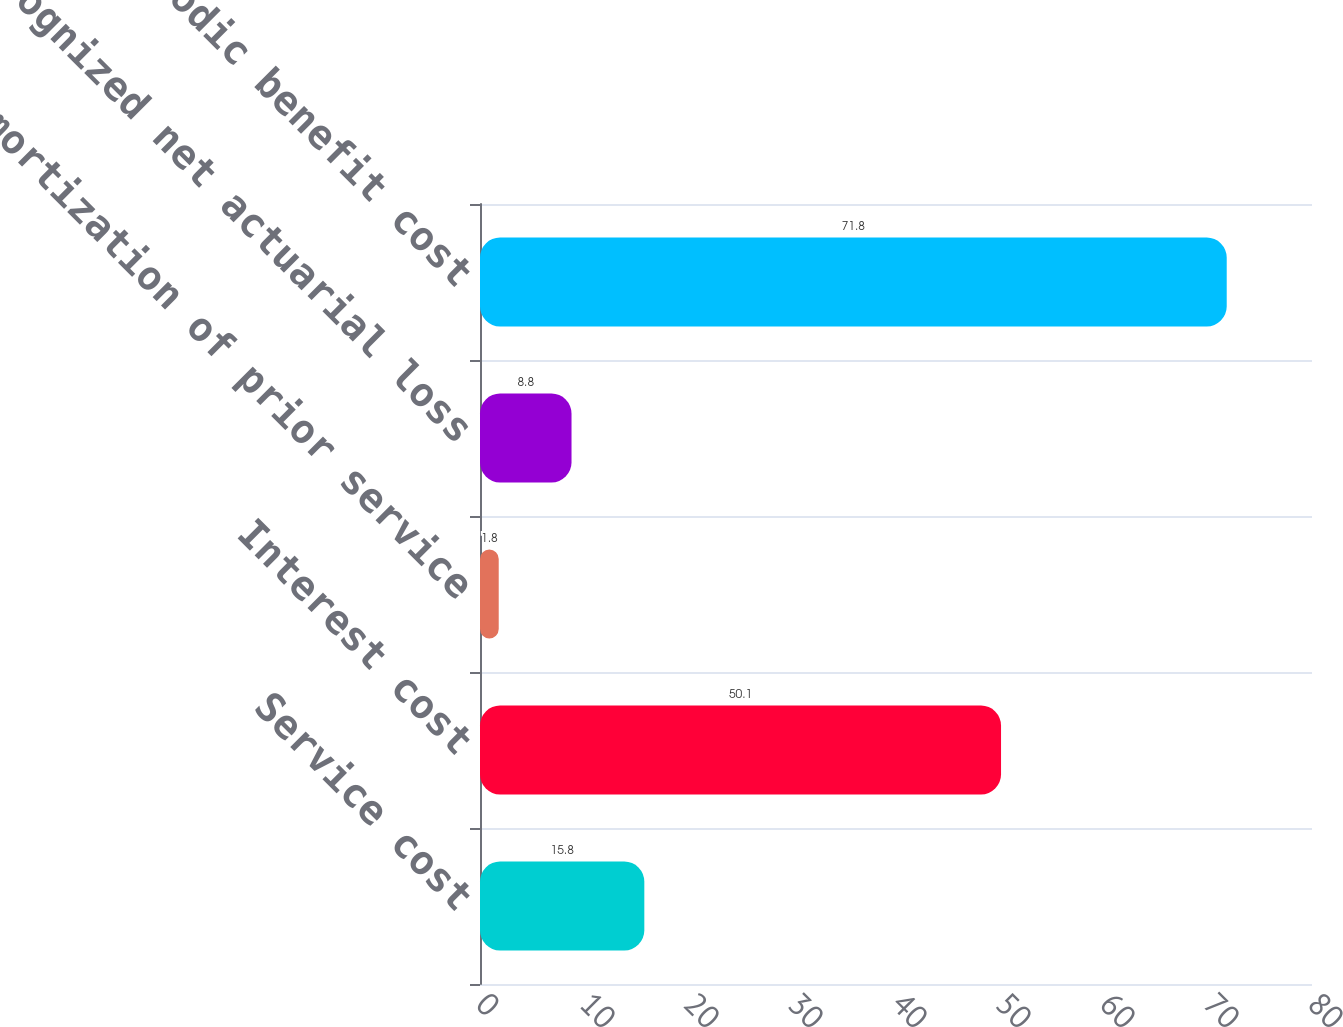Convert chart to OTSL. <chart><loc_0><loc_0><loc_500><loc_500><bar_chart><fcel>Service cost<fcel>Interest cost<fcel>Amortization of prior service<fcel>Recognized net actuarial loss<fcel>Net periodic benefit cost<nl><fcel>15.8<fcel>50.1<fcel>1.8<fcel>8.8<fcel>71.8<nl></chart> 